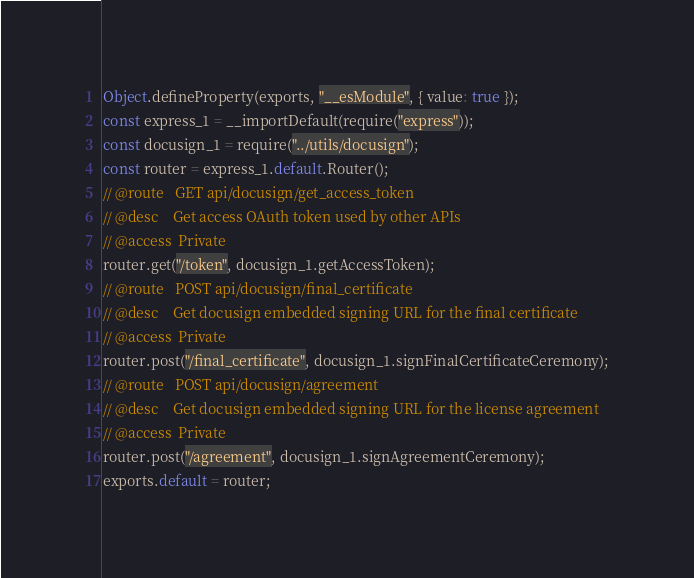<code> <loc_0><loc_0><loc_500><loc_500><_JavaScript_>Object.defineProperty(exports, "__esModule", { value: true });
const express_1 = __importDefault(require("express"));
const docusign_1 = require("../utils/docusign");
const router = express_1.default.Router();
// @route   GET api/docusign/get_access_token
// @desc    Get access OAuth token used by other APIs
// @access  Private
router.get("/token", docusign_1.getAccessToken);
// @route   POST api/docusign/final_certificate
// @desc    Get docusign embedded signing URL for the final certificate
// @access  Private
router.post("/final_certificate", docusign_1.signFinalCertificateCeremony);
// @route   POST api/docusign/agreement
// @desc    Get docusign embedded signing URL for the license agreement
// @access  Private
router.post("/agreement", docusign_1.signAgreementCeremony);
exports.default = router;
</code> 